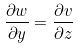<formula> <loc_0><loc_0><loc_500><loc_500>\frac { \partial w } { \partial y } = \frac { \partial v } { \partial z }</formula> 